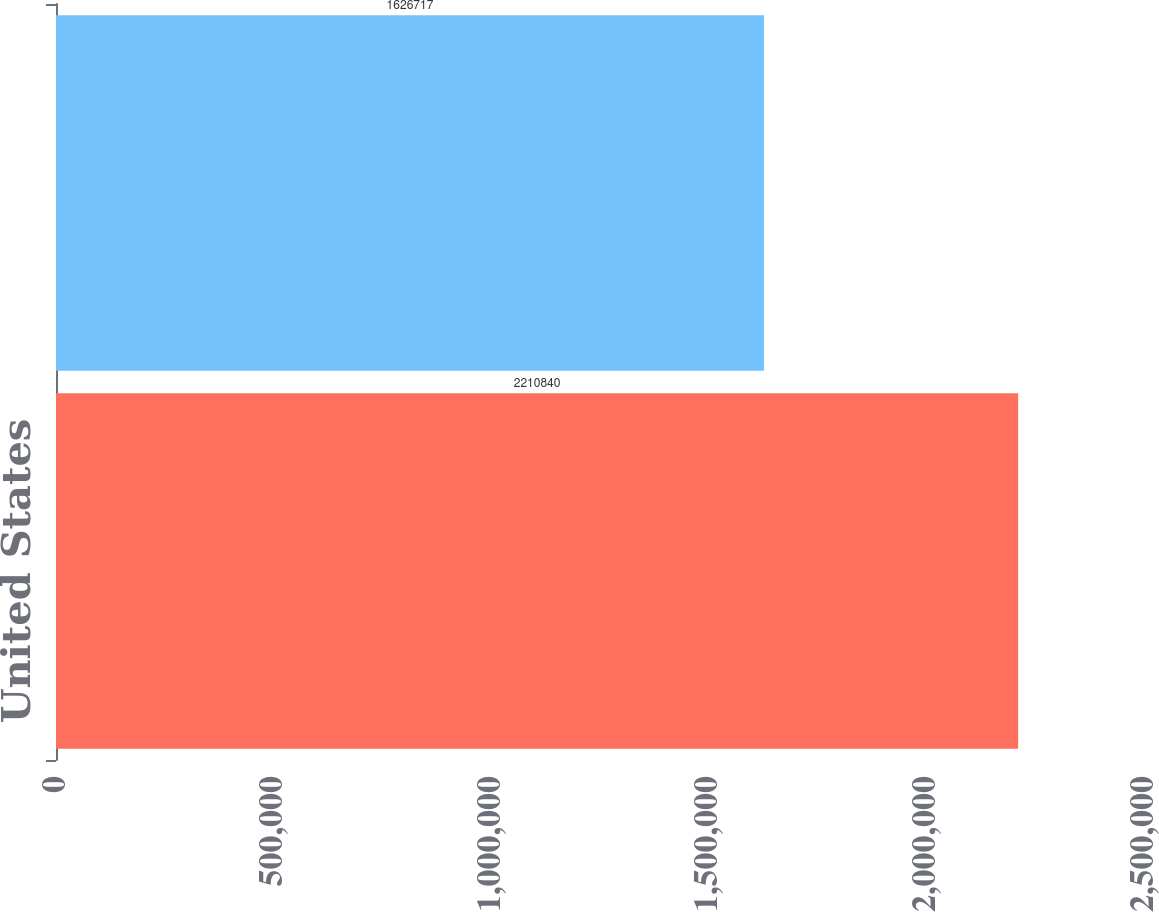Convert chart. <chart><loc_0><loc_0><loc_500><loc_500><bar_chart><fcel>United States<fcel>International<nl><fcel>2.21084e+06<fcel>1.62672e+06<nl></chart> 